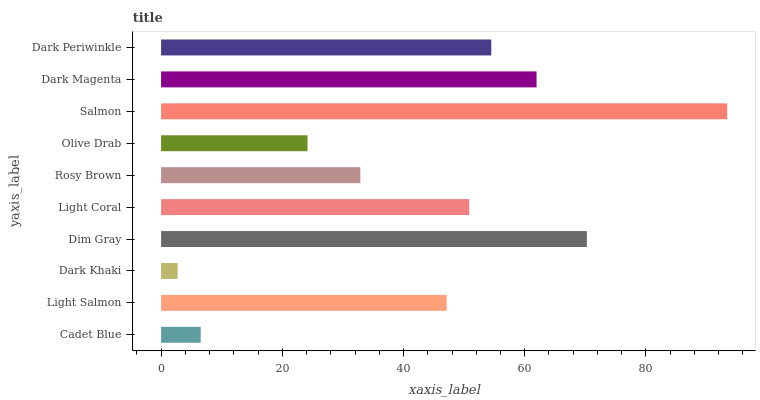Is Dark Khaki the minimum?
Answer yes or no. Yes. Is Salmon the maximum?
Answer yes or no. Yes. Is Light Salmon the minimum?
Answer yes or no. No. Is Light Salmon the maximum?
Answer yes or no. No. Is Light Salmon greater than Cadet Blue?
Answer yes or no. Yes. Is Cadet Blue less than Light Salmon?
Answer yes or no. Yes. Is Cadet Blue greater than Light Salmon?
Answer yes or no. No. Is Light Salmon less than Cadet Blue?
Answer yes or no. No. Is Light Coral the high median?
Answer yes or no. Yes. Is Light Salmon the low median?
Answer yes or no. Yes. Is Salmon the high median?
Answer yes or no. No. Is Rosy Brown the low median?
Answer yes or no. No. 